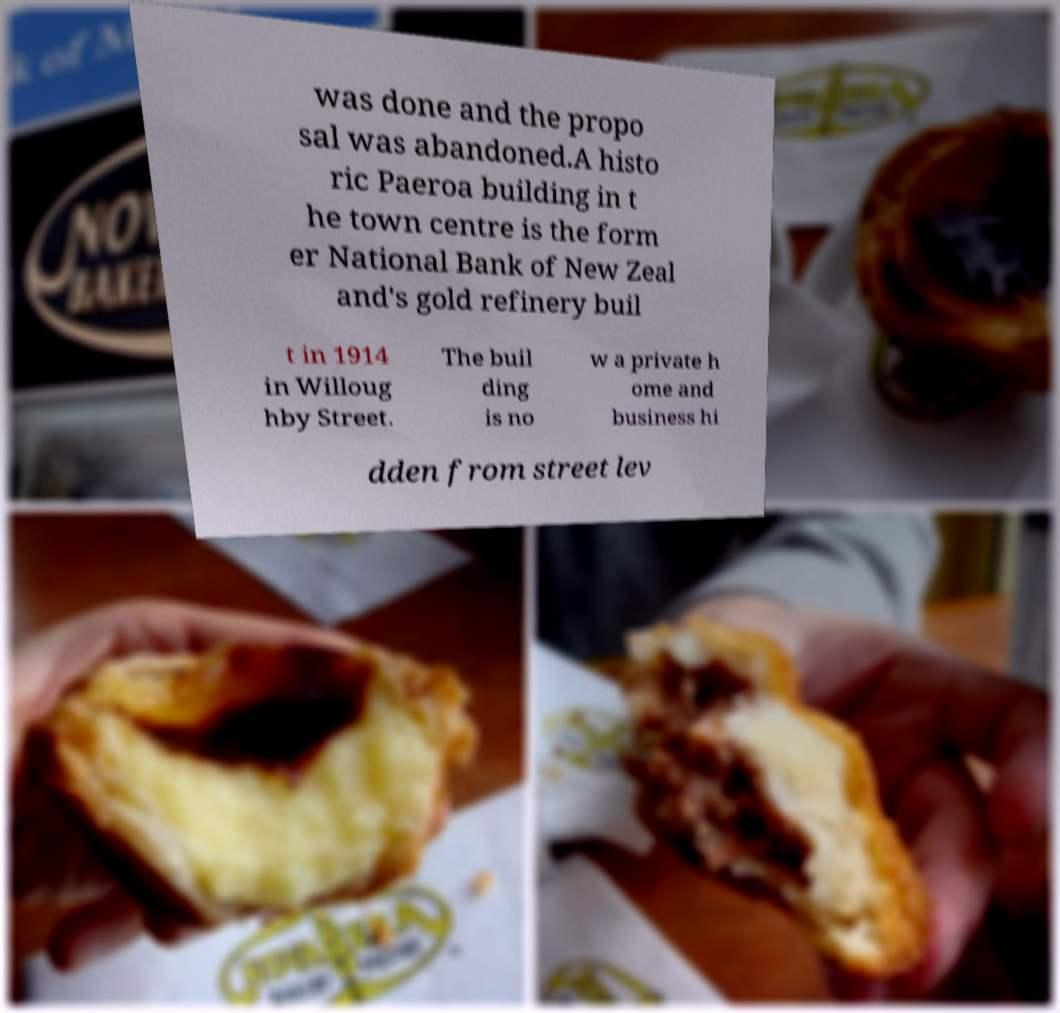Please identify and transcribe the text found in this image. was done and the propo sal was abandoned.A histo ric Paeroa building in t he town centre is the form er National Bank of New Zeal and's gold refinery buil t in 1914 in Willoug hby Street. The buil ding is no w a private h ome and business hi dden from street lev 